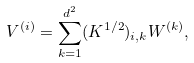<formula> <loc_0><loc_0><loc_500><loc_500>V ^ { ( i ) } = \sum _ { k = 1 } ^ { d ^ { 2 } } ( K ^ { 1 / 2 } ) _ { i , k } W ^ { ( k ) } ,</formula> 